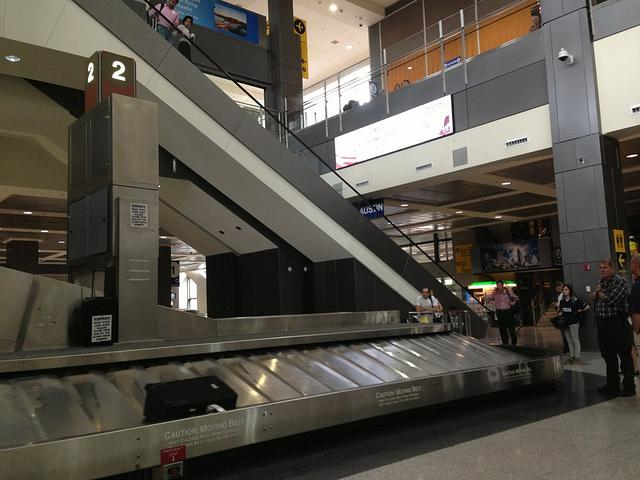What color is the suitcase on the luggage rack underneath the number two? Please explain your reasoning. black. The suitcase is black. 